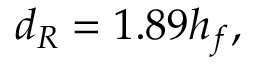Convert formula to latex. <formula><loc_0><loc_0><loc_500><loc_500>d _ { R } = 1 . 8 9 h _ { f } ,</formula> 